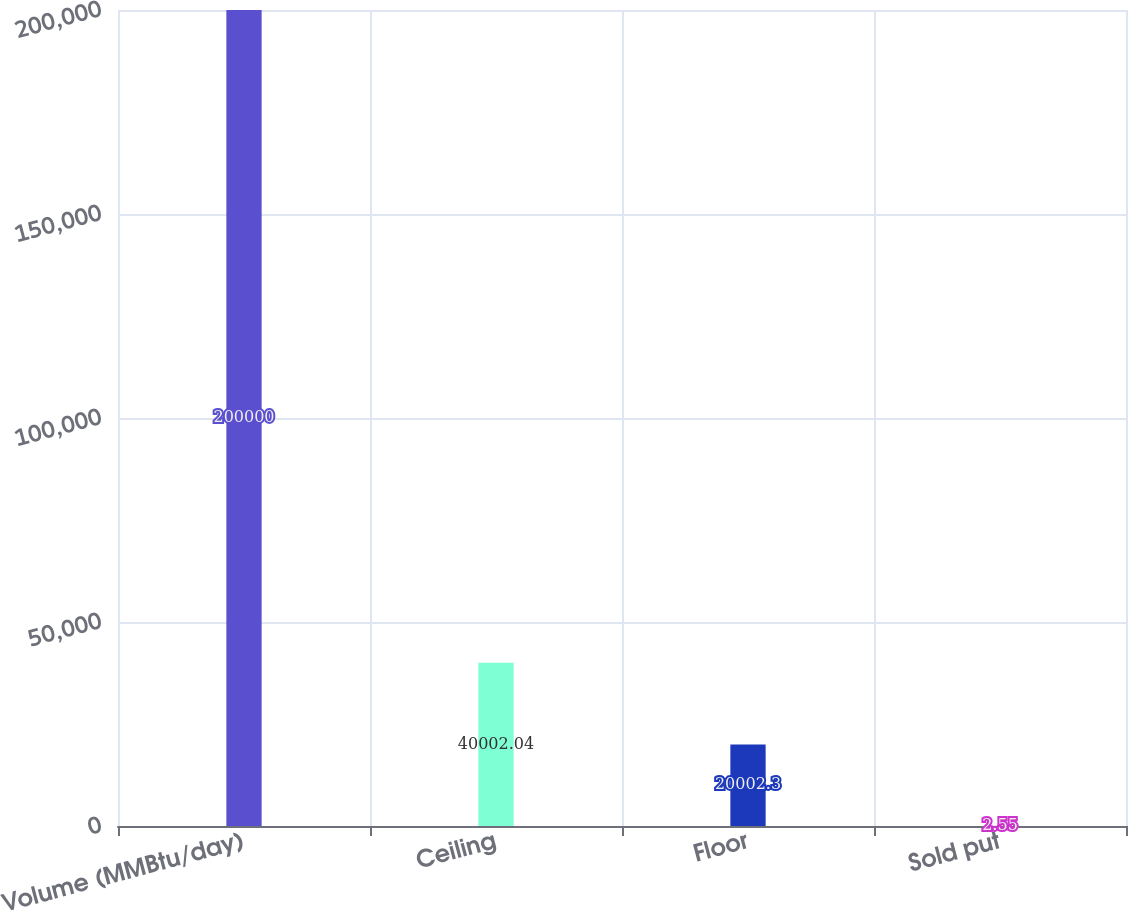Convert chart to OTSL. <chart><loc_0><loc_0><loc_500><loc_500><bar_chart><fcel>Volume (MMBtu/day)<fcel>Ceiling<fcel>Floor<fcel>Sold put<nl><fcel>200000<fcel>40002<fcel>20002.3<fcel>2.55<nl></chart> 